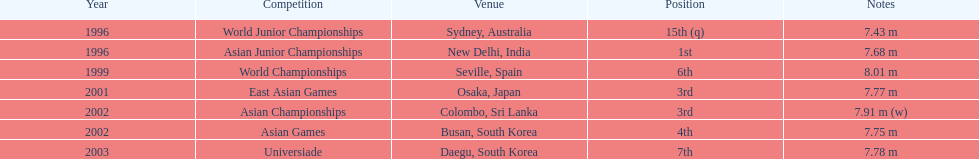What year marked the first time the 3rd position was achieved? 2001. 